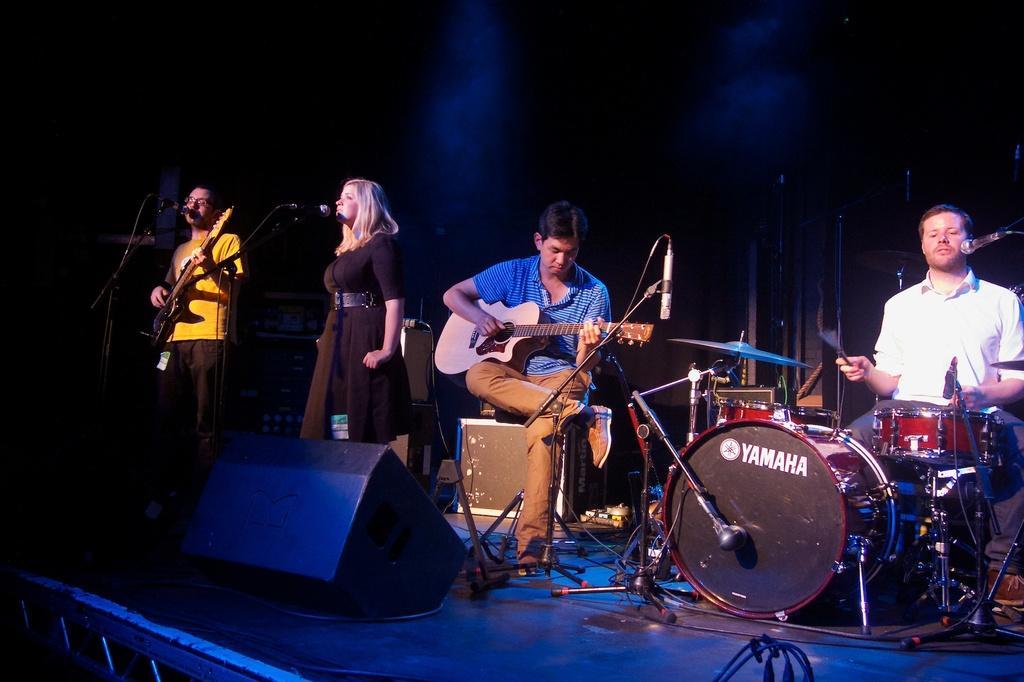Describe this image in one or two sentences. The picture is taken on the stage where four people are performing, at the right corner one man is sitting and playing drums beside him one man is sitting on the chair and playing guitar and left corner of the picture one woman is standing in a black singing in front of the microphone, beside her one person is playing a guitar. 